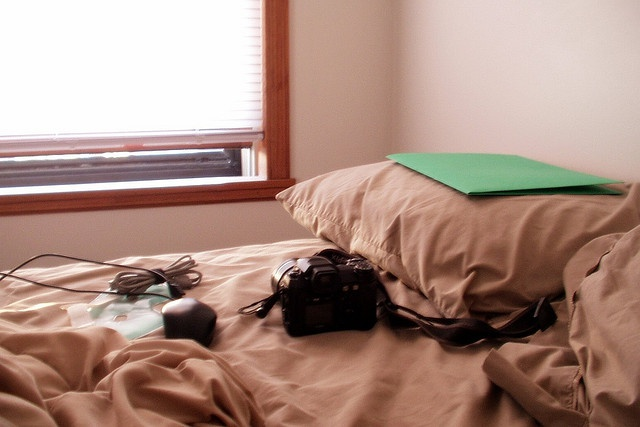Describe the objects in this image and their specific colors. I can see bed in white, brown, tan, maroon, and salmon tones and mouse in white, black, lightgray, maroon, and darkgray tones in this image. 